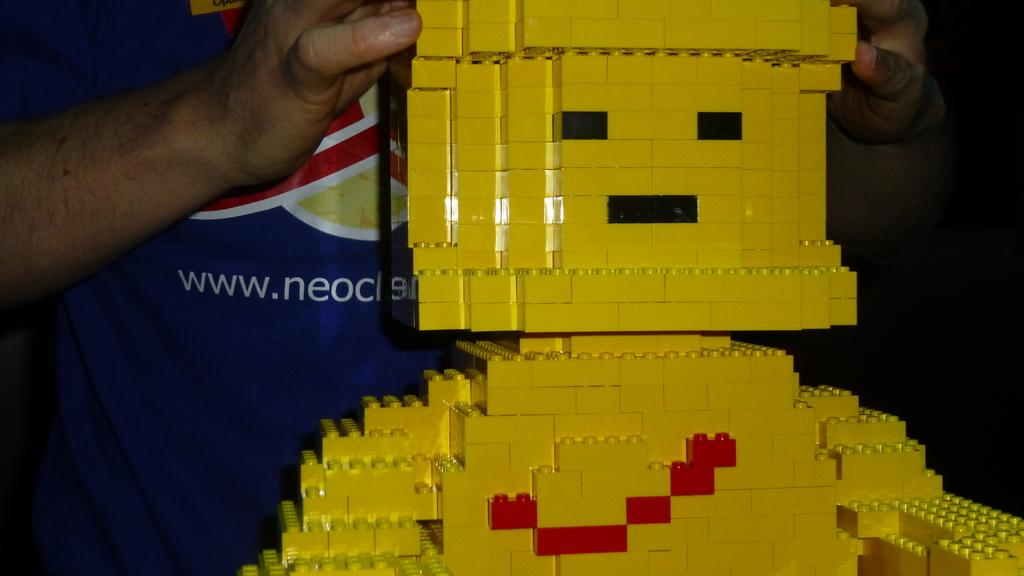What color are the bricks in the image? The bricks in the image are yellow. Who is holding the bricks? A person is holding the bricks. What color clothes can be seen in the background of the image? Blue color clothes can be seen in the background of the image. How many trees are visible in the image? There are no trees visible in the image; it only shows yellow bricks, a person holding them, and blue color clothes in the background. 